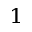<formula> <loc_0><loc_0><loc_500><loc_500>^ { 1 }</formula> 